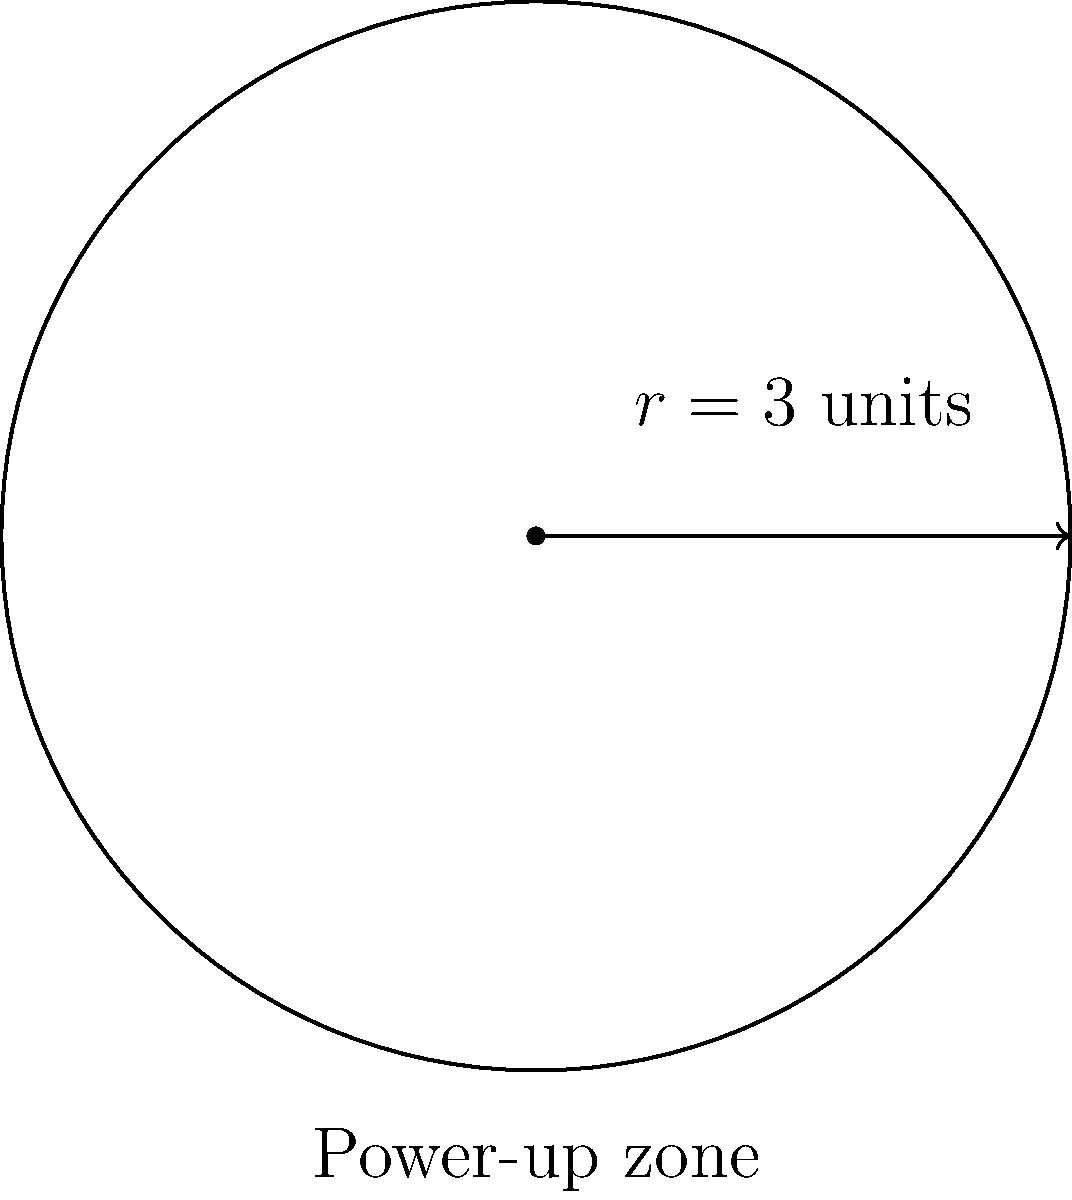In a top-down shooter game, there's a circular power-up zone with a radius of 3 units. Players need to navigate around its perimeter to collect bonuses. What's the distance a player would travel to complete one lap around this power-up zone? Let's break this down into simple steps:

1) The shape of the power-up zone is a circle.

2) We're asked to find the perimeter of this circle, which is also known as its circumference.

3) The formula for the circumference of a circle is:

   $$C = 2\pi r$$

   Where:
   $C$ is the circumference
   $\pi$ (pi) is approximately 3.14159
   $r$ is the radius

4) We're given that the radius is 3 units.

5) Let's plug this into our formula:

   $$C = 2\pi(3)$$

6) Simplify:
   $$C = 6\pi$$

7) If we want a decimal approximation:
   $$C \approx 6 * 3.14159 \approx 18.85 \text{ units}$$

So, a player would travel approximately 18.85 units to complete one lap around the power-up zone.
Answer: $6\pi$ units (or approximately 18.85 units) 